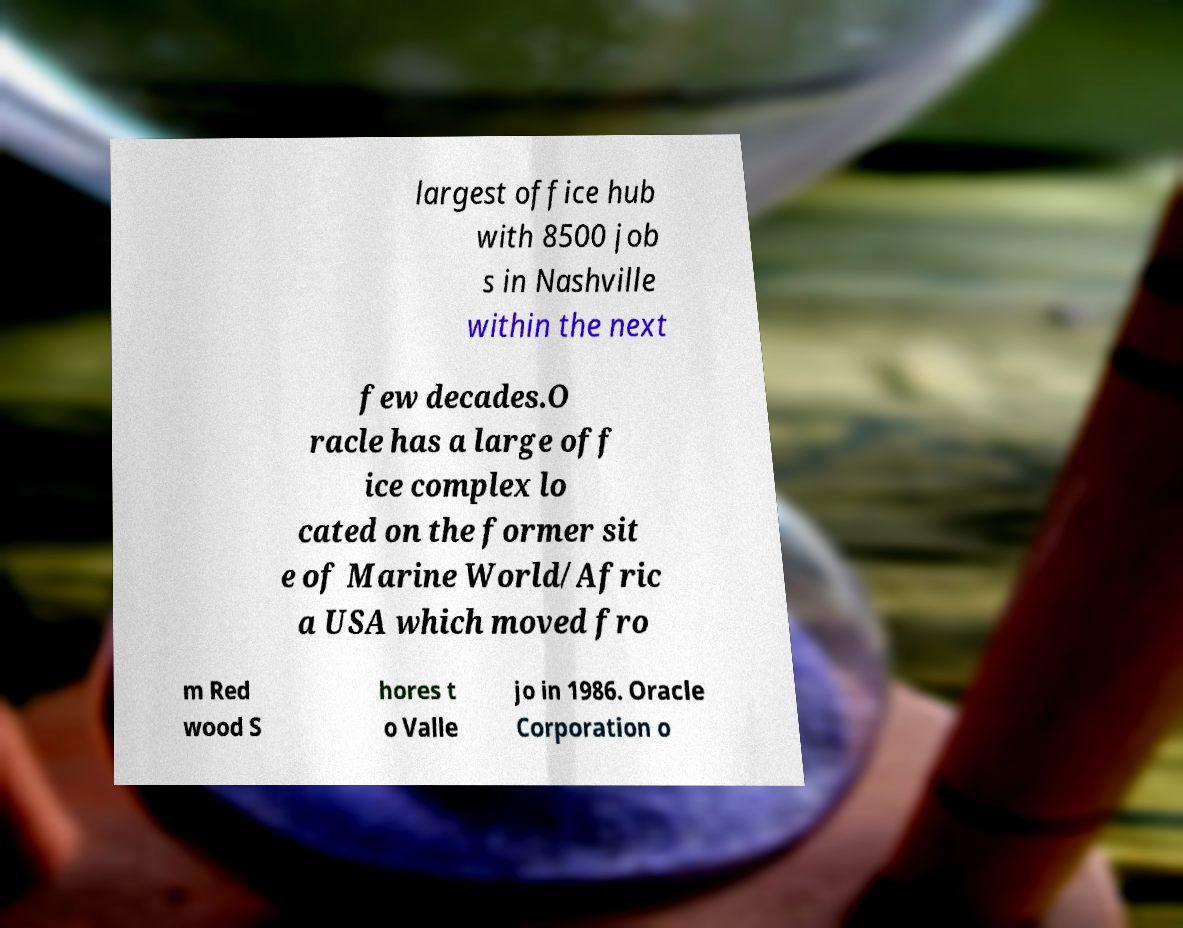I need the written content from this picture converted into text. Can you do that? largest office hub with 8500 job s in Nashville within the next few decades.O racle has a large off ice complex lo cated on the former sit e of Marine World/Afric a USA which moved fro m Red wood S hores t o Valle jo in 1986. Oracle Corporation o 